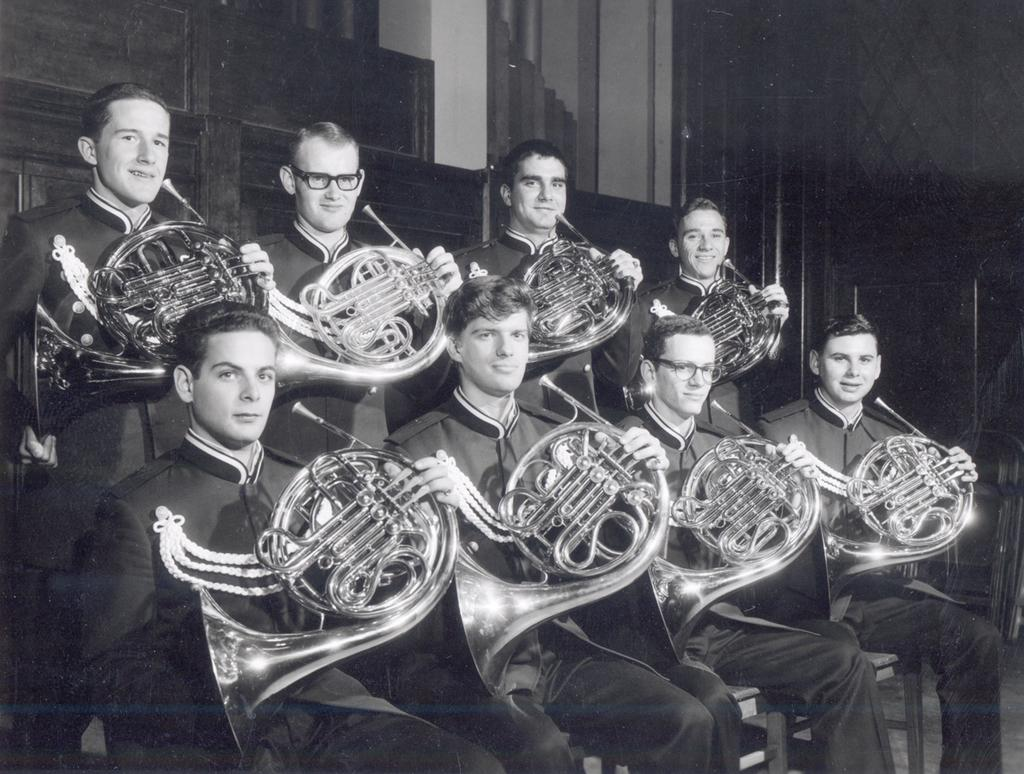What are the people in the image doing? The people in the image are sitting. What are the people holding while sitting? The people are holding musical instruments. What type of bread is the grandmother eating in the image? There is no grandmother or bread present in the image. 